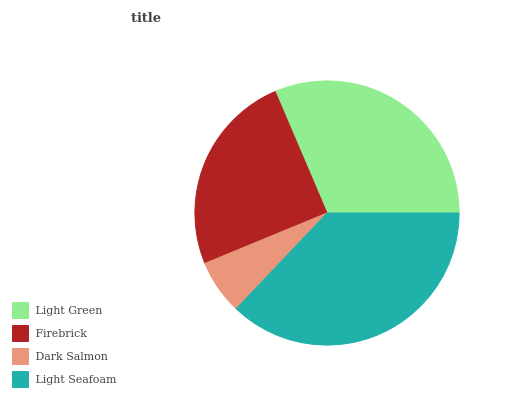Is Dark Salmon the minimum?
Answer yes or no. Yes. Is Light Seafoam the maximum?
Answer yes or no. Yes. Is Firebrick the minimum?
Answer yes or no. No. Is Firebrick the maximum?
Answer yes or no. No. Is Light Green greater than Firebrick?
Answer yes or no. Yes. Is Firebrick less than Light Green?
Answer yes or no. Yes. Is Firebrick greater than Light Green?
Answer yes or no. No. Is Light Green less than Firebrick?
Answer yes or no. No. Is Light Green the high median?
Answer yes or no. Yes. Is Firebrick the low median?
Answer yes or no. Yes. Is Light Seafoam the high median?
Answer yes or no. No. Is Light Green the low median?
Answer yes or no. No. 